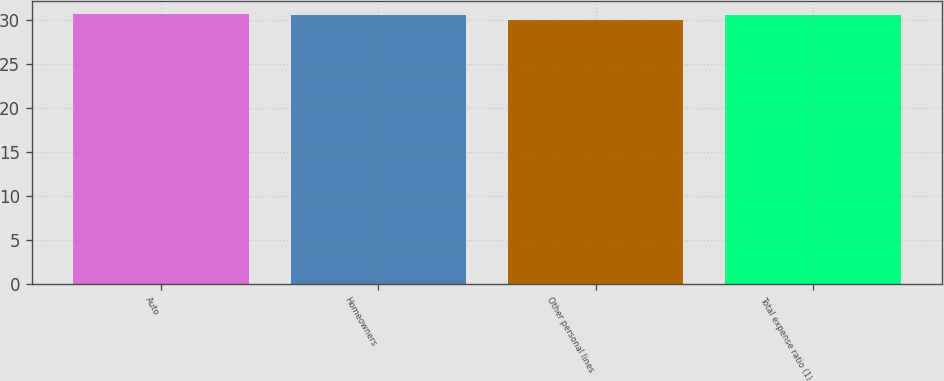Convert chart to OTSL. <chart><loc_0><loc_0><loc_500><loc_500><bar_chart><fcel>Auto<fcel>Homeowners<fcel>Other personal lines<fcel>Total expense ratio (1)<nl><fcel>30.72<fcel>30.6<fcel>30.1<fcel>30.66<nl></chart> 